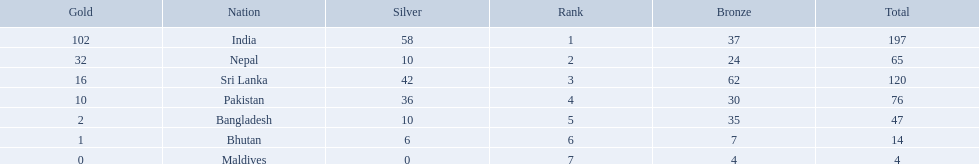What are the totals of medals one in each country? 197, 65, 120, 76, 47, 14, 4. Which of these totals are less than 10? 4. Who won this number of medals? Maldives. What were the total amount won of medals by nations in the 1999 south asian games? 197, 65, 120, 76, 47, 14, 4. Which amount was the lowest? 4. Which nation had this amount? Maldives. 